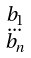Convert formula to latex. <formula><loc_0><loc_0><loc_500><loc_500>\begin{smallmatrix} b _ { 1 } \\ \dots \\ b _ { n } \\ \end{smallmatrix}</formula> 